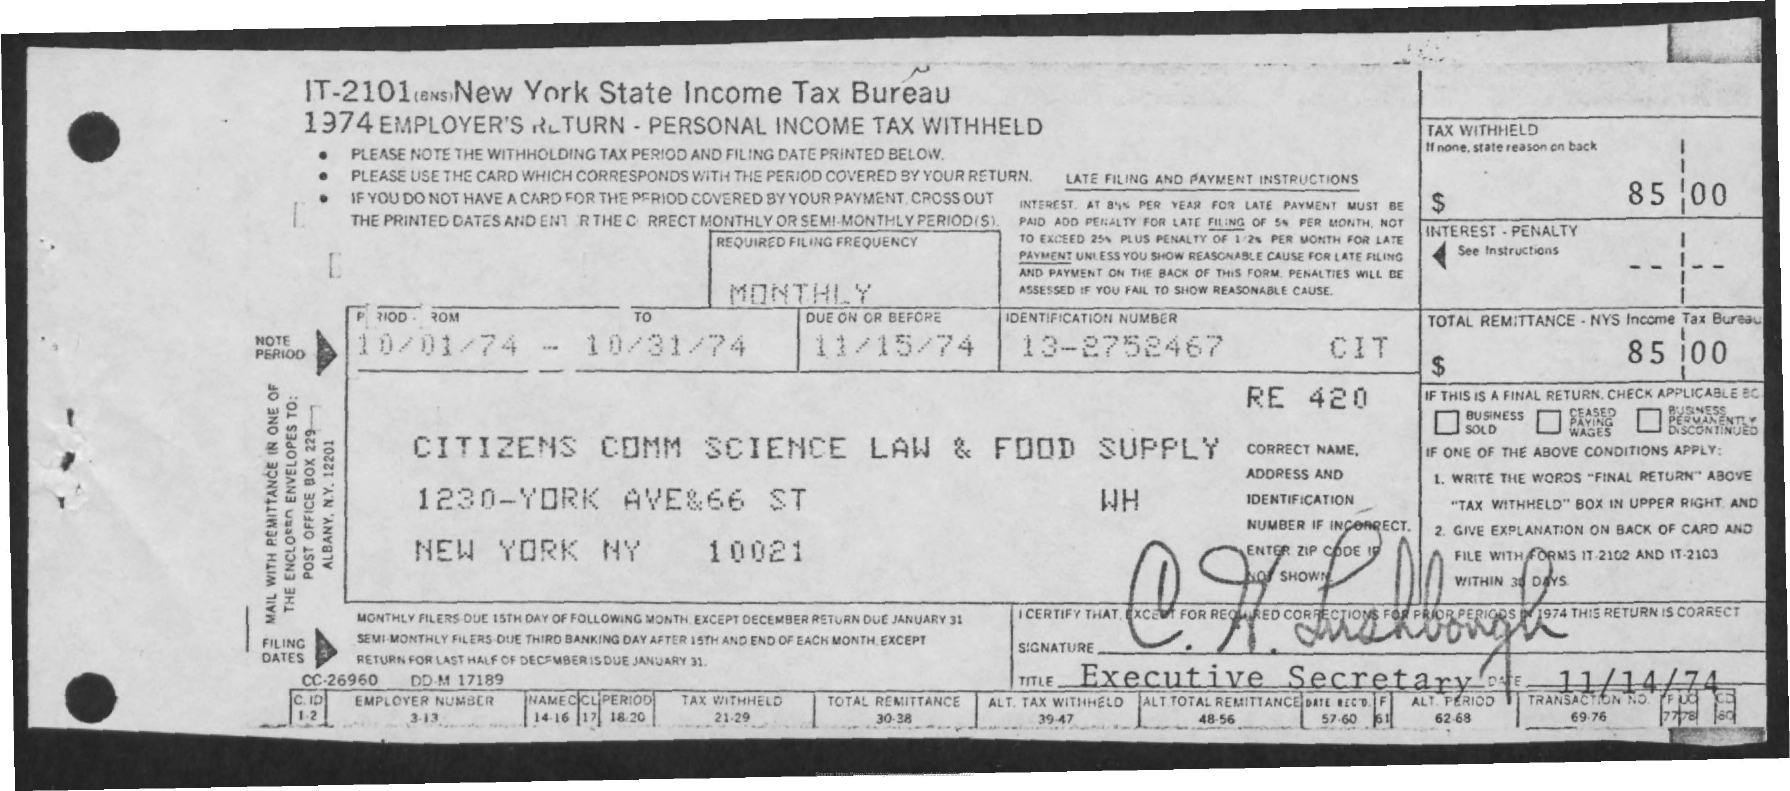What is the amount mentioned?
Your answer should be very brief. 85.00. 